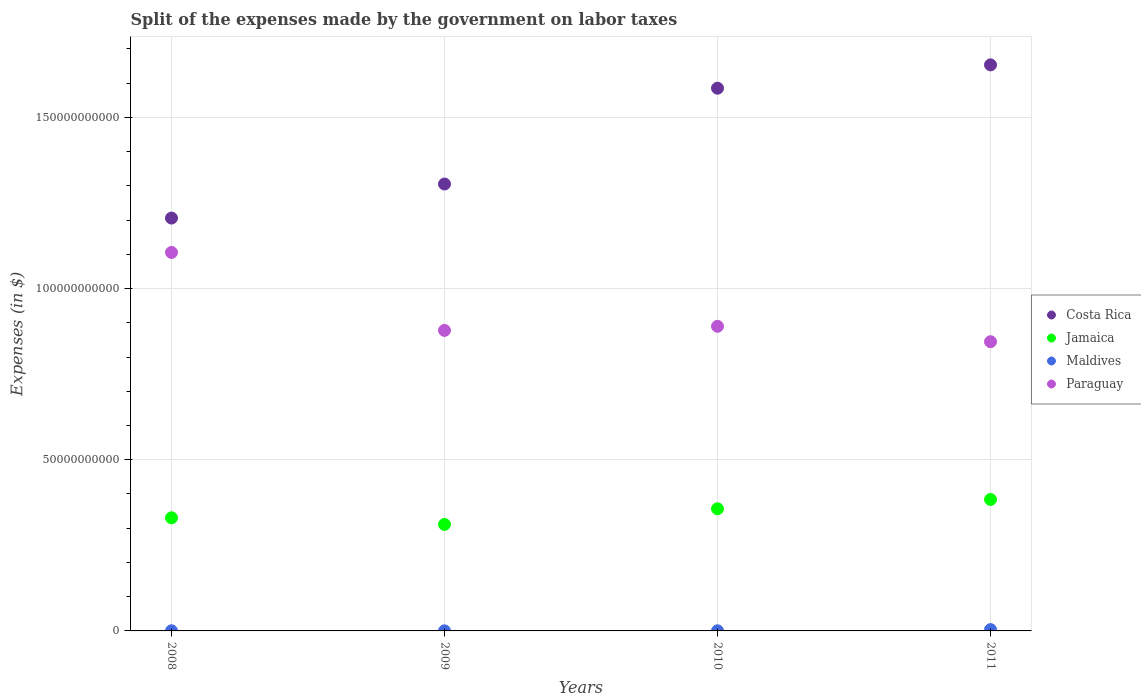Is the number of dotlines equal to the number of legend labels?
Ensure brevity in your answer.  Yes. What is the expenses made by the government on labor taxes in Costa Rica in 2009?
Offer a very short reply. 1.31e+11. Across all years, what is the maximum expenses made by the government on labor taxes in Jamaica?
Offer a terse response. 3.84e+1. Across all years, what is the minimum expenses made by the government on labor taxes in Costa Rica?
Give a very brief answer. 1.21e+11. In which year was the expenses made by the government on labor taxes in Costa Rica maximum?
Your response must be concise. 2011. In which year was the expenses made by the government on labor taxes in Maldives minimum?
Give a very brief answer. 2009. What is the total expenses made by the government on labor taxes in Maldives in the graph?
Offer a terse response. 4.86e+08. What is the difference between the expenses made by the government on labor taxes in Maldives in 2009 and that in 2010?
Offer a very short reply. -9.80e+06. What is the difference between the expenses made by the government on labor taxes in Costa Rica in 2009 and the expenses made by the government on labor taxes in Paraguay in 2008?
Offer a very short reply. 2.00e+1. What is the average expenses made by the government on labor taxes in Costa Rica per year?
Provide a succinct answer. 1.44e+11. In the year 2011, what is the difference between the expenses made by the government on labor taxes in Jamaica and expenses made by the government on labor taxes in Maldives?
Your answer should be very brief. 3.80e+1. What is the ratio of the expenses made by the government on labor taxes in Jamaica in 2010 to that in 2011?
Your answer should be compact. 0.93. Is the difference between the expenses made by the government on labor taxes in Jamaica in 2010 and 2011 greater than the difference between the expenses made by the government on labor taxes in Maldives in 2010 and 2011?
Your answer should be compact. No. What is the difference between the highest and the second highest expenses made by the government on labor taxes in Costa Rica?
Your response must be concise. 6.81e+09. What is the difference between the highest and the lowest expenses made by the government on labor taxes in Paraguay?
Your response must be concise. 2.61e+1. In how many years, is the expenses made by the government on labor taxes in Paraguay greater than the average expenses made by the government on labor taxes in Paraguay taken over all years?
Make the answer very short. 1. Is the sum of the expenses made by the government on labor taxes in Costa Rica in 2008 and 2010 greater than the maximum expenses made by the government on labor taxes in Paraguay across all years?
Your answer should be very brief. Yes. Is it the case that in every year, the sum of the expenses made by the government on labor taxes in Jamaica and expenses made by the government on labor taxes in Maldives  is greater than the sum of expenses made by the government on labor taxes in Paraguay and expenses made by the government on labor taxes in Costa Rica?
Your answer should be very brief. Yes. Does the expenses made by the government on labor taxes in Costa Rica monotonically increase over the years?
Make the answer very short. Yes. Is the expenses made by the government on labor taxes in Maldives strictly less than the expenses made by the government on labor taxes in Paraguay over the years?
Provide a succinct answer. Yes. What is the difference between two consecutive major ticks on the Y-axis?
Provide a short and direct response. 5.00e+1. Are the values on the major ticks of Y-axis written in scientific E-notation?
Offer a terse response. No. Does the graph contain grids?
Give a very brief answer. Yes. Where does the legend appear in the graph?
Make the answer very short. Center right. How many legend labels are there?
Make the answer very short. 4. What is the title of the graph?
Your answer should be very brief. Split of the expenses made by the government on labor taxes. What is the label or title of the Y-axis?
Ensure brevity in your answer.  Expenses (in $). What is the Expenses (in $) of Costa Rica in 2008?
Offer a terse response. 1.21e+11. What is the Expenses (in $) of Jamaica in 2008?
Your answer should be compact. 3.30e+1. What is the Expenses (in $) in Maldives in 2008?
Your answer should be compact. 3.97e+07. What is the Expenses (in $) in Paraguay in 2008?
Offer a very short reply. 1.11e+11. What is the Expenses (in $) of Costa Rica in 2009?
Your answer should be very brief. 1.31e+11. What is the Expenses (in $) of Jamaica in 2009?
Your answer should be compact. 3.11e+1. What is the Expenses (in $) of Maldives in 2009?
Make the answer very short. 2.71e+07. What is the Expenses (in $) of Paraguay in 2009?
Your answer should be very brief. 8.78e+1. What is the Expenses (in $) in Costa Rica in 2010?
Give a very brief answer. 1.59e+11. What is the Expenses (in $) in Jamaica in 2010?
Keep it short and to the point. 3.57e+1. What is the Expenses (in $) of Maldives in 2010?
Provide a short and direct response. 3.69e+07. What is the Expenses (in $) in Paraguay in 2010?
Make the answer very short. 8.90e+1. What is the Expenses (in $) of Costa Rica in 2011?
Provide a succinct answer. 1.65e+11. What is the Expenses (in $) of Jamaica in 2011?
Provide a short and direct response. 3.84e+1. What is the Expenses (in $) in Maldives in 2011?
Keep it short and to the point. 3.83e+08. What is the Expenses (in $) of Paraguay in 2011?
Offer a terse response. 8.45e+1. Across all years, what is the maximum Expenses (in $) in Costa Rica?
Keep it short and to the point. 1.65e+11. Across all years, what is the maximum Expenses (in $) of Jamaica?
Provide a short and direct response. 3.84e+1. Across all years, what is the maximum Expenses (in $) in Maldives?
Offer a very short reply. 3.83e+08. Across all years, what is the maximum Expenses (in $) of Paraguay?
Your answer should be very brief. 1.11e+11. Across all years, what is the minimum Expenses (in $) of Costa Rica?
Your answer should be very brief. 1.21e+11. Across all years, what is the minimum Expenses (in $) in Jamaica?
Make the answer very short. 3.11e+1. Across all years, what is the minimum Expenses (in $) of Maldives?
Ensure brevity in your answer.  2.71e+07. Across all years, what is the minimum Expenses (in $) in Paraguay?
Provide a short and direct response. 8.45e+1. What is the total Expenses (in $) of Costa Rica in the graph?
Offer a terse response. 5.75e+11. What is the total Expenses (in $) in Jamaica in the graph?
Offer a terse response. 1.38e+11. What is the total Expenses (in $) in Maldives in the graph?
Offer a terse response. 4.86e+08. What is the total Expenses (in $) in Paraguay in the graph?
Make the answer very short. 3.72e+11. What is the difference between the Expenses (in $) in Costa Rica in 2008 and that in 2009?
Give a very brief answer. -9.94e+09. What is the difference between the Expenses (in $) of Jamaica in 2008 and that in 2009?
Your answer should be compact. 1.94e+09. What is the difference between the Expenses (in $) in Maldives in 2008 and that in 2009?
Ensure brevity in your answer.  1.26e+07. What is the difference between the Expenses (in $) of Paraguay in 2008 and that in 2009?
Provide a short and direct response. 2.28e+1. What is the difference between the Expenses (in $) of Costa Rica in 2008 and that in 2010?
Provide a succinct answer. -3.79e+1. What is the difference between the Expenses (in $) of Jamaica in 2008 and that in 2010?
Keep it short and to the point. -2.64e+09. What is the difference between the Expenses (in $) in Maldives in 2008 and that in 2010?
Make the answer very short. 2.80e+06. What is the difference between the Expenses (in $) of Paraguay in 2008 and that in 2010?
Offer a very short reply. 2.16e+1. What is the difference between the Expenses (in $) of Costa Rica in 2008 and that in 2011?
Your response must be concise. -4.47e+1. What is the difference between the Expenses (in $) in Jamaica in 2008 and that in 2011?
Ensure brevity in your answer.  -5.36e+09. What is the difference between the Expenses (in $) of Maldives in 2008 and that in 2011?
Make the answer very short. -3.43e+08. What is the difference between the Expenses (in $) of Paraguay in 2008 and that in 2011?
Offer a very short reply. 2.61e+1. What is the difference between the Expenses (in $) of Costa Rica in 2009 and that in 2010?
Offer a terse response. -2.80e+1. What is the difference between the Expenses (in $) in Jamaica in 2009 and that in 2010?
Your response must be concise. -4.58e+09. What is the difference between the Expenses (in $) of Maldives in 2009 and that in 2010?
Make the answer very short. -9.80e+06. What is the difference between the Expenses (in $) in Paraguay in 2009 and that in 2010?
Your answer should be compact. -1.20e+09. What is the difference between the Expenses (in $) of Costa Rica in 2009 and that in 2011?
Provide a short and direct response. -3.48e+1. What is the difference between the Expenses (in $) in Jamaica in 2009 and that in 2011?
Keep it short and to the point. -7.30e+09. What is the difference between the Expenses (in $) of Maldives in 2009 and that in 2011?
Keep it short and to the point. -3.55e+08. What is the difference between the Expenses (in $) in Paraguay in 2009 and that in 2011?
Give a very brief answer. 3.30e+09. What is the difference between the Expenses (in $) in Costa Rica in 2010 and that in 2011?
Give a very brief answer. -6.81e+09. What is the difference between the Expenses (in $) in Jamaica in 2010 and that in 2011?
Your answer should be very brief. -2.72e+09. What is the difference between the Expenses (in $) of Maldives in 2010 and that in 2011?
Offer a terse response. -3.46e+08. What is the difference between the Expenses (in $) of Paraguay in 2010 and that in 2011?
Keep it short and to the point. 4.50e+09. What is the difference between the Expenses (in $) in Costa Rica in 2008 and the Expenses (in $) in Jamaica in 2009?
Your answer should be very brief. 8.95e+1. What is the difference between the Expenses (in $) of Costa Rica in 2008 and the Expenses (in $) of Maldives in 2009?
Provide a short and direct response. 1.21e+11. What is the difference between the Expenses (in $) of Costa Rica in 2008 and the Expenses (in $) of Paraguay in 2009?
Give a very brief answer. 3.28e+1. What is the difference between the Expenses (in $) of Jamaica in 2008 and the Expenses (in $) of Maldives in 2009?
Provide a succinct answer. 3.30e+1. What is the difference between the Expenses (in $) in Jamaica in 2008 and the Expenses (in $) in Paraguay in 2009?
Your answer should be very brief. -5.47e+1. What is the difference between the Expenses (in $) of Maldives in 2008 and the Expenses (in $) of Paraguay in 2009?
Make the answer very short. -8.77e+1. What is the difference between the Expenses (in $) in Costa Rica in 2008 and the Expenses (in $) in Jamaica in 2010?
Offer a very short reply. 8.49e+1. What is the difference between the Expenses (in $) in Costa Rica in 2008 and the Expenses (in $) in Maldives in 2010?
Offer a terse response. 1.21e+11. What is the difference between the Expenses (in $) of Costa Rica in 2008 and the Expenses (in $) of Paraguay in 2010?
Make the answer very short. 3.16e+1. What is the difference between the Expenses (in $) of Jamaica in 2008 and the Expenses (in $) of Maldives in 2010?
Give a very brief answer. 3.30e+1. What is the difference between the Expenses (in $) in Jamaica in 2008 and the Expenses (in $) in Paraguay in 2010?
Provide a short and direct response. -5.59e+1. What is the difference between the Expenses (in $) of Maldives in 2008 and the Expenses (in $) of Paraguay in 2010?
Your response must be concise. -8.89e+1. What is the difference between the Expenses (in $) in Costa Rica in 2008 and the Expenses (in $) in Jamaica in 2011?
Ensure brevity in your answer.  8.22e+1. What is the difference between the Expenses (in $) in Costa Rica in 2008 and the Expenses (in $) in Maldives in 2011?
Ensure brevity in your answer.  1.20e+11. What is the difference between the Expenses (in $) in Costa Rica in 2008 and the Expenses (in $) in Paraguay in 2011?
Make the answer very short. 3.61e+1. What is the difference between the Expenses (in $) of Jamaica in 2008 and the Expenses (in $) of Maldives in 2011?
Make the answer very short. 3.27e+1. What is the difference between the Expenses (in $) of Jamaica in 2008 and the Expenses (in $) of Paraguay in 2011?
Your answer should be very brief. -5.14e+1. What is the difference between the Expenses (in $) of Maldives in 2008 and the Expenses (in $) of Paraguay in 2011?
Keep it short and to the point. -8.44e+1. What is the difference between the Expenses (in $) in Costa Rica in 2009 and the Expenses (in $) in Jamaica in 2010?
Provide a succinct answer. 9.49e+1. What is the difference between the Expenses (in $) in Costa Rica in 2009 and the Expenses (in $) in Maldives in 2010?
Make the answer very short. 1.30e+11. What is the difference between the Expenses (in $) of Costa Rica in 2009 and the Expenses (in $) of Paraguay in 2010?
Provide a succinct answer. 4.16e+1. What is the difference between the Expenses (in $) in Jamaica in 2009 and the Expenses (in $) in Maldives in 2010?
Offer a very short reply. 3.11e+1. What is the difference between the Expenses (in $) of Jamaica in 2009 and the Expenses (in $) of Paraguay in 2010?
Your answer should be compact. -5.79e+1. What is the difference between the Expenses (in $) in Maldives in 2009 and the Expenses (in $) in Paraguay in 2010?
Offer a very short reply. -8.89e+1. What is the difference between the Expenses (in $) of Costa Rica in 2009 and the Expenses (in $) of Jamaica in 2011?
Your response must be concise. 9.21e+1. What is the difference between the Expenses (in $) in Costa Rica in 2009 and the Expenses (in $) in Maldives in 2011?
Your answer should be very brief. 1.30e+11. What is the difference between the Expenses (in $) of Costa Rica in 2009 and the Expenses (in $) of Paraguay in 2011?
Your response must be concise. 4.61e+1. What is the difference between the Expenses (in $) in Jamaica in 2009 and the Expenses (in $) in Maldives in 2011?
Offer a terse response. 3.07e+1. What is the difference between the Expenses (in $) in Jamaica in 2009 and the Expenses (in $) in Paraguay in 2011?
Keep it short and to the point. -5.34e+1. What is the difference between the Expenses (in $) in Maldives in 2009 and the Expenses (in $) in Paraguay in 2011?
Provide a short and direct response. -8.44e+1. What is the difference between the Expenses (in $) in Costa Rica in 2010 and the Expenses (in $) in Jamaica in 2011?
Your answer should be very brief. 1.20e+11. What is the difference between the Expenses (in $) of Costa Rica in 2010 and the Expenses (in $) of Maldives in 2011?
Your answer should be very brief. 1.58e+11. What is the difference between the Expenses (in $) of Costa Rica in 2010 and the Expenses (in $) of Paraguay in 2011?
Make the answer very short. 7.40e+1. What is the difference between the Expenses (in $) in Jamaica in 2010 and the Expenses (in $) in Maldives in 2011?
Offer a terse response. 3.53e+1. What is the difference between the Expenses (in $) of Jamaica in 2010 and the Expenses (in $) of Paraguay in 2011?
Your answer should be very brief. -4.88e+1. What is the difference between the Expenses (in $) in Maldives in 2010 and the Expenses (in $) in Paraguay in 2011?
Your response must be concise. -8.44e+1. What is the average Expenses (in $) in Costa Rica per year?
Provide a short and direct response. 1.44e+11. What is the average Expenses (in $) in Jamaica per year?
Your answer should be compact. 3.46e+1. What is the average Expenses (in $) of Maldives per year?
Offer a very short reply. 1.22e+08. What is the average Expenses (in $) of Paraguay per year?
Ensure brevity in your answer.  9.29e+1. In the year 2008, what is the difference between the Expenses (in $) in Costa Rica and Expenses (in $) in Jamaica?
Provide a short and direct response. 8.75e+1. In the year 2008, what is the difference between the Expenses (in $) of Costa Rica and Expenses (in $) of Maldives?
Your response must be concise. 1.21e+11. In the year 2008, what is the difference between the Expenses (in $) of Costa Rica and Expenses (in $) of Paraguay?
Give a very brief answer. 1.00e+1. In the year 2008, what is the difference between the Expenses (in $) of Jamaica and Expenses (in $) of Maldives?
Make the answer very short. 3.30e+1. In the year 2008, what is the difference between the Expenses (in $) in Jamaica and Expenses (in $) in Paraguay?
Provide a short and direct response. -7.75e+1. In the year 2008, what is the difference between the Expenses (in $) of Maldives and Expenses (in $) of Paraguay?
Ensure brevity in your answer.  -1.11e+11. In the year 2009, what is the difference between the Expenses (in $) in Costa Rica and Expenses (in $) in Jamaica?
Offer a terse response. 9.94e+1. In the year 2009, what is the difference between the Expenses (in $) of Costa Rica and Expenses (in $) of Maldives?
Provide a succinct answer. 1.31e+11. In the year 2009, what is the difference between the Expenses (in $) of Costa Rica and Expenses (in $) of Paraguay?
Provide a short and direct response. 4.28e+1. In the year 2009, what is the difference between the Expenses (in $) in Jamaica and Expenses (in $) in Maldives?
Offer a very short reply. 3.11e+1. In the year 2009, what is the difference between the Expenses (in $) of Jamaica and Expenses (in $) of Paraguay?
Keep it short and to the point. -5.67e+1. In the year 2009, what is the difference between the Expenses (in $) in Maldives and Expenses (in $) in Paraguay?
Give a very brief answer. -8.77e+1. In the year 2010, what is the difference between the Expenses (in $) in Costa Rica and Expenses (in $) in Jamaica?
Offer a terse response. 1.23e+11. In the year 2010, what is the difference between the Expenses (in $) of Costa Rica and Expenses (in $) of Maldives?
Keep it short and to the point. 1.58e+11. In the year 2010, what is the difference between the Expenses (in $) in Costa Rica and Expenses (in $) in Paraguay?
Your answer should be compact. 6.95e+1. In the year 2010, what is the difference between the Expenses (in $) in Jamaica and Expenses (in $) in Maldives?
Your answer should be very brief. 3.56e+1. In the year 2010, what is the difference between the Expenses (in $) of Jamaica and Expenses (in $) of Paraguay?
Give a very brief answer. -5.33e+1. In the year 2010, what is the difference between the Expenses (in $) in Maldives and Expenses (in $) in Paraguay?
Offer a very short reply. -8.89e+1. In the year 2011, what is the difference between the Expenses (in $) of Costa Rica and Expenses (in $) of Jamaica?
Offer a very short reply. 1.27e+11. In the year 2011, what is the difference between the Expenses (in $) in Costa Rica and Expenses (in $) in Maldives?
Your answer should be very brief. 1.65e+11. In the year 2011, what is the difference between the Expenses (in $) in Costa Rica and Expenses (in $) in Paraguay?
Make the answer very short. 8.09e+1. In the year 2011, what is the difference between the Expenses (in $) in Jamaica and Expenses (in $) in Maldives?
Offer a very short reply. 3.80e+1. In the year 2011, what is the difference between the Expenses (in $) of Jamaica and Expenses (in $) of Paraguay?
Offer a terse response. -4.61e+1. In the year 2011, what is the difference between the Expenses (in $) of Maldives and Expenses (in $) of Paraguay?
Your answer should be very brief. -8.41e+1. What is the ratio of the Expenses (in $) of Costa Rica in 2008 to that in 2009?
Keep it short and to the point. 0.92. What is the ratio of the Expenses (in $) of Jamaica in 2008 to that in 2009?
Provide a succinct answer. 1.06. What is the ratio of the Expenses (in $) of Maldives in 2008 to that in 2009?
Make the answer very short. 1.46. What is the ratio of the Expenses (in $) of Paraguay in 2008 to that in 2009?
Make the answer very short. 1.26. What is the ratio of the Expenses (in $) of Costa Rica in 2008 to that in 2010?
Provide a succinct answer. 0.76. What is the ratio of the Expenses (in $) of Jamaica in 2008 to that in 2010?
Provide a succinct answer. 0.93. What is the ratio of the Expenses (in $) in Maldives in 2008 to that in 2010?
Provide a succinct answer. 1.08. What is the ratio of the Expenses (in $) of Paraguay in 2008 to that in 2010?
Your response must be concise. 1.24. What is the ratio of the Expenses (in $) in Costa Rica in 2008 to that in 2011?
Offer a terse response. 0.73. What is the ratio of the Expenses (in $) of Jamaica in 2008 to that in 2011?
Keep it short and to the point. 0.86. What is the ratio of the Expenses (in $) of Maldives in 2008 to that in 2011?
Provide a short and direct response. 0.1. What is the ratio of the Expenses (in $) of Paraguay in 2008 to that in 2011?
Provide a short and direct response. 1.31. What is the ratio of the Expenses (in $) in Costa Rica in 2009 to that in 2010?
Give a very brief answer. 0.82. What is the ratio of the Expenses (in $) in Jamaica in 2009 to that in 2010?
Offer a very short reply. 0.87. What is the ratio of the Expenses (in $) in Maldives in 2009 to that in 2010?
Offer a very short reply. 0.73. What is the ratio of the Expenses (in $) in Paraguay in 2009 to that in 2010?
Your answer should be very brief. 0.99. What is the ratio of the Expenses (in $) of Costa Rica in 2009 to that in 2011?
Your answer should be compact. 0.79. What is the ratio of the Expenses (in $) of Jamaica in 2009 to that in 2011?
Your response must be concise. 0.81. What is the ratio of the Expenses (in $) in Maldives in 2009 to that in 2011?
Offer a very short reply. 0.07. What is the ratio of the Expenses (in $) of Paraguay in 2009 to that in 2011?
Offer a very short reply. 1.04. What is the ratio of the Expenses (in $) of Costa Rica in 2010 to that in 2011?
Provide a succinct answer. 0.96. What is the ratio of the Expenses (in $) of Jamaica in 2010 to that in 2011?
Offer a very short reply. 0.93. What is the ratio of the Expenses (in $) of Maldives in 2010 to that in 2011?
Offer a terse response. 0.1. What is the ratio of the Expenses (in $) in Paraguay in 2010 to that in 2011?
Offer a very short reply. 1.05. What is the difference between the highest and the second highest Expenses (in $) in Costa Rica?
Ensure brevity in your answer.  6.81e+09. What is the difference between the highest and the second highest Expenses (in $) in Jamaica?
Provide a succinct answer. 2.72e+09. What is the difference between the highest and the second highest Expenses (in $) in Maldives?
Your answer should be very brief. 3.43e+08. What is the difference between the highest and the second highest Expenses (in $) of Paraguay?
Offer a very short reply. 2.16e+1. What is the difference between the highest and the lowest Expenses (in $) of Costa Rica?
Provide a succinct answer. 4.47e+1. What is the difference between the highest and the lowest Expenses (in $) of Jamaica?
Your answer should be very brief. 7.30e+09. What is the difference between the highest and the lowest Expenses (in $) of Maldives?
Offer a very short reply. 3.55e+08. What is the difference between the highest and the lowest Expenses (in $) in Paraguay?
Provide a short and direct response. 2.61e+1. 